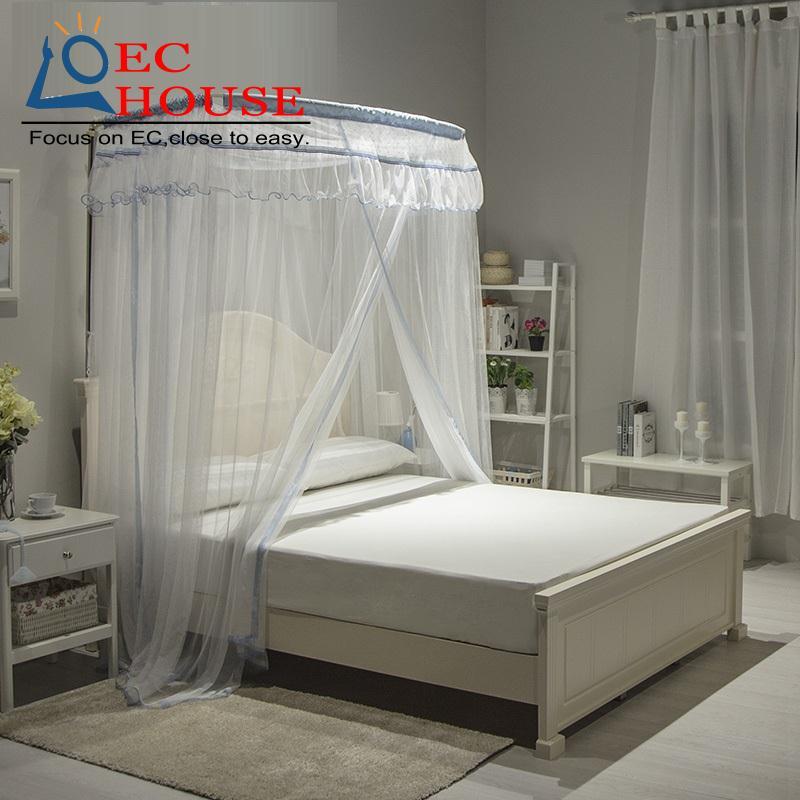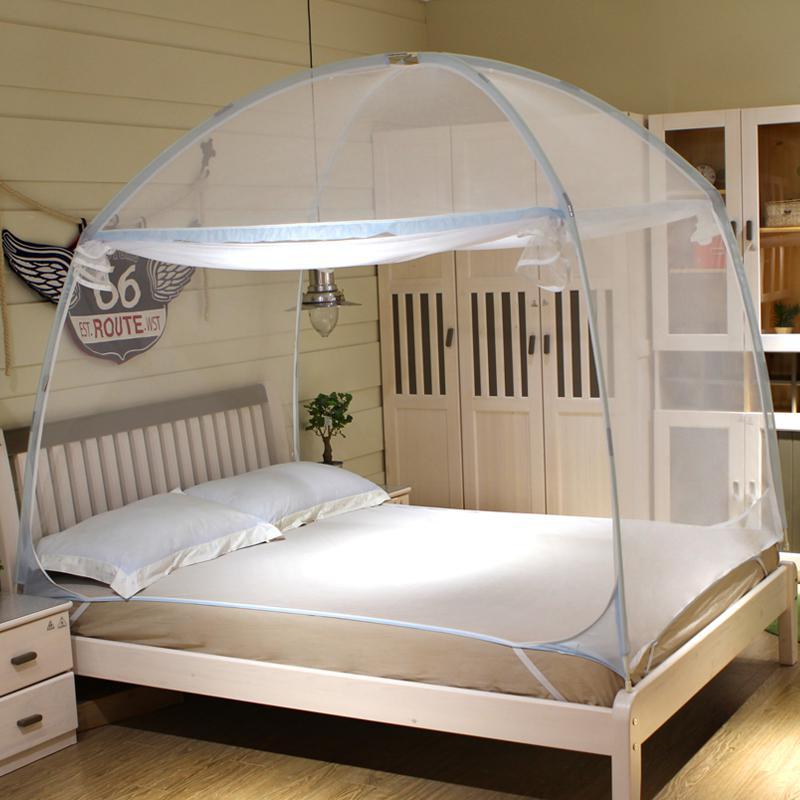The first image is the image on the left, the second image is the image on the right. Considering the images on both sides, is "Drapes cover half of the bed in the left image and a tent like dome covers the whole bed in the right image." valid? Answer yes or no. Yes. The first image is the image on the left, the second image is the image on the right. For the images displayed, is the sentence "There is a rounded net sitting over the bed in the image on the right." factually correct? Answer yes or no. Yes. 